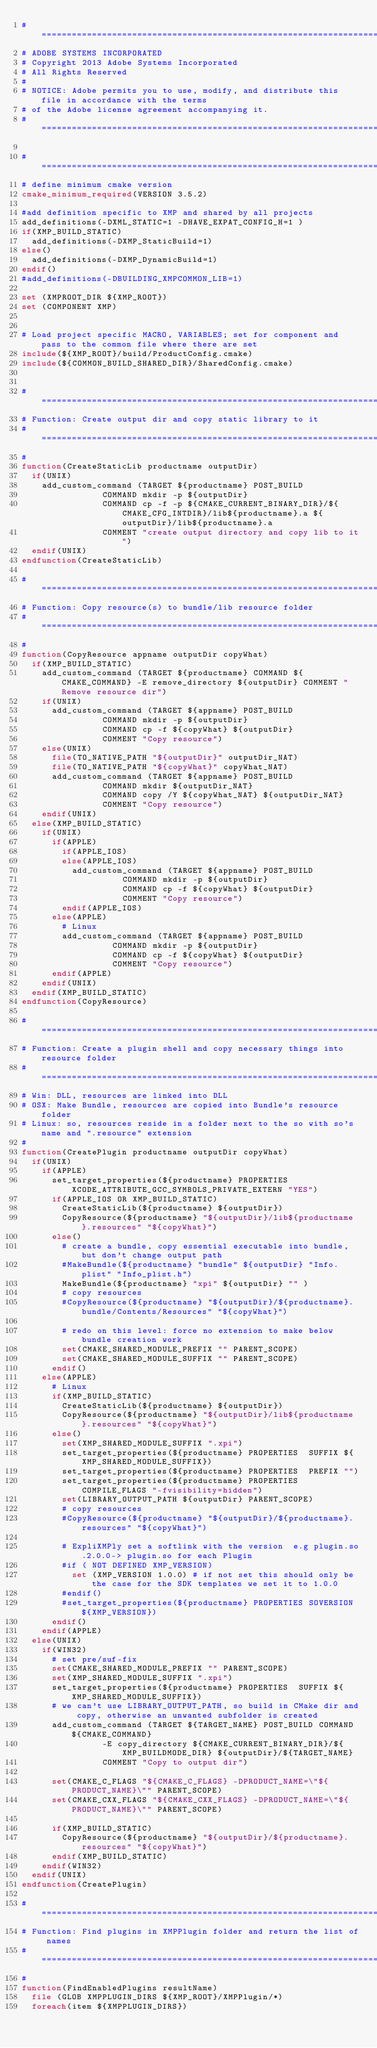<code> <loc_0><loc_0><loc_500><loc_500><_CMake_># =================================================================================================
# ADOBE SYSTEMS INCORPORATED
# Copyright 2013 Adobe Systems Incorporated
# All Rights Reserved
#
# NOTICE: Adobe permits you to use, modify, and distribute this file in accordance with the terms
# of the Adobe license agreement accompanying it.
# =================================================================================================

# ==============================================================================
# define minimum cmake version
cmake_minimum_required(VERSION 3.5.2)

#add definition specific to XMP and shared by all projects
add_definitions(-DXML_STATIC=1 -DHAVE_EXPAT_CONFIG_H=1 )
if(XMP_BUILD_STATIC)
	add_definitions(-DXMP_StaticBuild=1)
else()
	add_definitions(-DXMP_DynamicBuild=1)
endif()
#add_definitions(-DBUILDING_XMPCOMMON_LIB=1)

set (XMPROOT_DIR ${XMP_ROOT})
set (COMPONENT XMP)


# Load project specific MACRO, VARIABLES; set for component and pass to the common file where there are set
include(${XMP_ROOT}/build/ProductConfig.cmake)
include(${COMMON_BUILD_SHARED_DIR}/SharedConfig.cmake)


# ==============================================================================
# Function: Create output dir and copy static library to it
# ==============================================================================
#
function(CreateStaticLib productname outputDir)
	if(UNIX)
		add_custom_command (TARGET ${productname} POST_BUILD 
								COMMAND mkdir -p ${outputDir}
								COMMAND cp -f -p ${CMAKE_CURRENT_BINARY_DIR}/${CMAKE_CFG_INTDIR}/lib${productname}.a ${outputDir}/lib${productname}.a
								COMMENT "create output directory and copy lib to it")
	endif(UNIX)
endfunction(CreateStaticLib)

# ==============================================================================
# Function: Copy resource(s) to bundle/lib resource folder
# ==============================================================================
#
function(CopyResource appname outputDir copyWhat)
	if(XMP_BUILD_STATIC)
		add_custom_command (TARGET ${productname} COMMAND ${CMAKE_COMMAND} -E remove_directory ${outputDir} COMMENT "Remove resource dir")
		if(UNIX)
			add_custom_command (TARGET ${appname} POST_BUILD 
								COMMAND mkdir -p ${outputDir}
								COMMAND cp -f ${copyWhat} ${outputDir}
								COMMENT "Copy resource")
		else(UNIX)
			file(TO_NATIVE_PATH "${outputDir}" outputDir_NAT)
			file(TO_NATIVE_PATH "${copyWhat}" copyWhat_NAT)
			add_custom_command (TARGET ${appname} POST_BUILD 
								COMMAND mkdir ${outputDir_NAT}
								COMMAND copy /Y ${copyWhat_NAT} ${outputDir_NAT}
								COMMENT "Copy resource")
		endif(UNIX)
	else(XMP_BUILD_STATIC)
		if(UNIX)
			if(APPLE)
				if(APPLE_IOS)
				else(APPLE_IOS)
					add_custom_command (TARGET ${appname} POST_BUILD 
										COMMAND mkdir -p ${outputDir}
										COMMAND cp -f ${copyWhat} ${outputDir}
										COMMENT "Copy resource")
				endif(APPLE_IOS)
			else(APPLE)
				# Linux
				add_custom_command (TARGET ${appname} POST_BUILD 
									COMMAND mkdir -p ${outputDir}
									COMMAND cp -f ${copyWhat} ${outputDir}
									COMMENT "Copy resource")
			endif(APPLE)
		endif(UNIX)
	endif(XMP_BUILD_STATIC)
endfunction(CopyResource)

# ==============================================================================
# Function: Create a plugin shell and copy necessary things into resource folder
# ==============================================================================
# Win: DLL, resources are linked into DLL
# OSX: Make Bundle, resources are copied into Bundle's resource folder
# Linux: so, resources reside in a folder next to the so with so's name and ".resource" extension
#
function(CreatePlugin productname outputDir copyWhat)
	if(UNIX)
		if(APPLE)
			set_target_properties(${productname} PROPERTIES XCODE_ATTRIBUTE_GCC_SYMBOLS_PRIVATE_EXTERN "YES") 
			if(APPLE_IOS OR XMP_BUILD_STATIC)
				CreateStaticLib(${productname} ${outputDir})
				CopyResource(${productname} "${outputDir}/lib${productname}.resources" "${copyWhat}")
			else()
				# create a bundle, copy essential executable into bundle, but don't change output path
				#MakeBundle(${productname} "bundle" ${outputDir} "Info.plist" "Info_plist.h")
				MakeBundle(${productname} "xpi" ${outputDir} "" )
				# copy resources
				#CopyResource(${productname} "${outputDir}/${productname}.bundle/Contents/Resources" "${copyWhat}")
			
				# redo on this level: force no extension to make below bundle creation work
				set(CMAKE_SHARED_MODULE_PREFIX "" PARENT_SCOPE)
				set(CMAKE_SHARED_MODULE_SUFFIX "" PARENT_SCOPE)
			endif()
		else(APPLE)
			# Linux
			if(XMP_BUILD_STATIC)
				CreateStaticLib(${productname} ${outputDir})
				CopyResource(${productname} "${outputDir}/lib${productname}.resources" "${copyWhat}")
			else()
				set(XMP_SHARED_MODULE_SUFFIX ".xpi")
				set_target_properties(${productname} PROPERTIES  SUFFIX ${XMP_SHARED_MODULE_SUFFIX})
				set_target_properties(${productname} PROPERTIES  PREFIX "")
				set_target_properties(${productname} PROPERTIES COMPILE_FLAGS "-fvisibility=hidden")
				set(LIBRARY_OUTPUT_PATH ${outputDir} PARENT_SCOPE)
				# copy resources
				#CopyResource(${productname} "${outputDir}/${productname}.resources" "${copyWhat}")
				
				# ExpliXMPly set a softlink with the version  e.g plugin.so.2.0.0-> plugin.so for each Plugin
				#if ( NOT DEFINED XMP_VERSION)
					set (XMP_VERSION 1.0.0) # if not set this should only be the case for the SDK templates we set it to 1.0.0
				#endif()
				#set_target_properties(${productname} PROPERTIES SOVERSION ${XMP_VERSION})
			endif()
		endif(APPLE)
	else(UNIX)
		if(WIN32)
			# set pre/suf-fix
			set(CMAKE_SHARED_MODULE_PREFIX "" PARENT_SCOPE)
			set(XMP_SHARED_MODULE_SUFFIX ".xpi")
			set_target_properties(${productname} PROPERTIES  SUFFIX ${XMP_SHARED_MODULE_SUFFIX})
			# we can't use LIBRARY_OUTPUT_PATH, so build in CMake dir and copy, otherwise an unwanted subfolder is created 
			add_custom_command (TARGET ${TARGET_NAME} POST_BUILD COMMAND ${CMAKE_COMMAND} 
								-E copy_directory ${CMAKE_CURRENT_BINARY_DIR}/${XMP_BUILDMODE_DIR} ${outputDir}/${TARGET_NAME}
								COMMENT "Copy to output dir")
			
			set(CMAKE_C_FLAGS "${CMAKE_C_FLAGS} -DPRODUCT_NAME=\"${PRODUCT_NAME}\"" PARENT_SCOPE)
			set(CMAKE_CXX_FLAGS "${CMAKE_CXX_FLAGS} -DPRODUCT_NAME=\"${PRODUCT_NAME}\"" PARENT_SCOPE)
			
			if(XMP_BUILD_STATIC)
				CopyResource(${productname} "${outputDir}/${productname}.resources" "${copyWhat}")
			endif(XMP_BUILD_STATIC)
		endif(WIN32)
	endif(UNIX)
endfunction(CreatePlugin)

# ==============================================================================
# Function: Find plugins in XMPPlugin folder and return the list of names
# ==============================================================================
#
function(FindEnabledPlugins resultName)
	file (GLOB XMPPLUGIN_DIRS ${XMP_ROOT}/XMPPlugin/*)
	foreach(item ${XMPPLUGIN_DIRS})</code> 